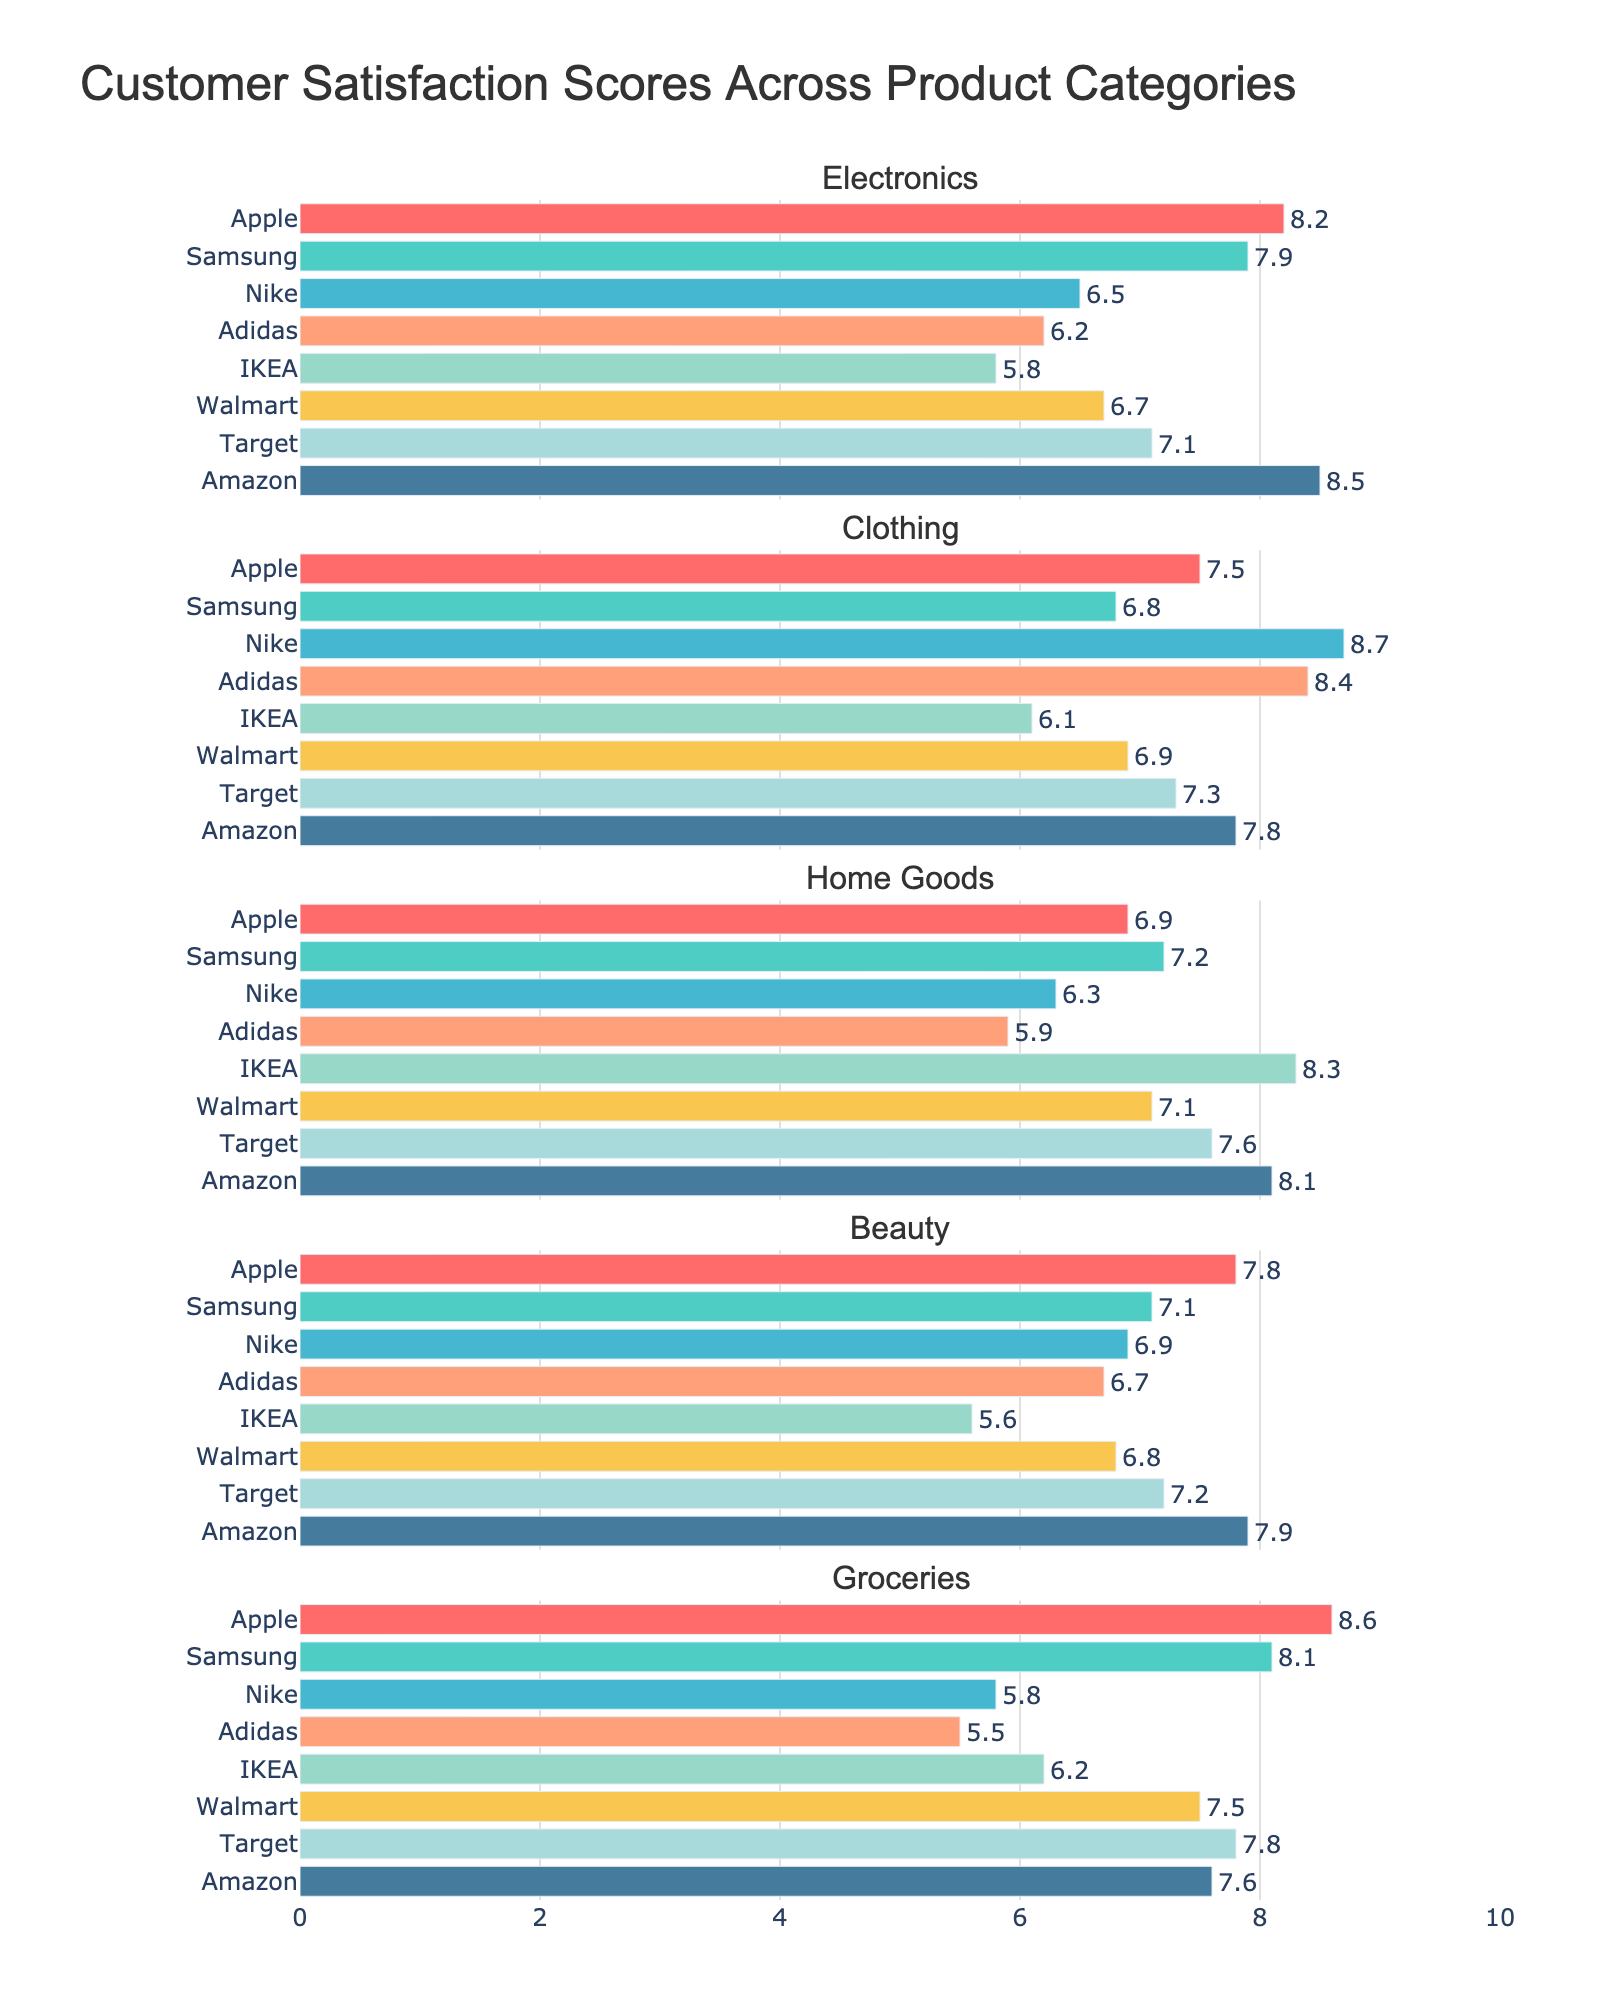What is the highest customer satisfaction score for Electronics? In the Electronics category subplot, identify the highest bar. The highest bar is for Amazon with a score of 8.5.
Answer: 8.5 Which brand has the lowest satisfaction score in the Beauty category? Look at the Beauty category subplot and identify the shortest bar. IKEA, with a score of 5.6, has the lowest satisfaction score.
Answer: IKEA What are the average satisfaction scores for Clothing and Home Goods categories? Calculate separately for each category by adding the scores and dividing by the number of brands. For Clothing: (7.5+6.8+8.7+8.4+6.1+6.9+7.3+7.8)/8 = 7.31; For Home Goods: (6.9+7.2+6.3+5.9+8.3+7.1+7.6+8.1)/8 = 7.05.
Answer: Clothing: 7.31, Home Goods: 7.05 Which two brands have the closest satisfaction scores in the Groceries category? Check the Groceries subplot and find the two bars with the closest heights. Apple (8.6) and Target (7.8) have the closest scores.
Answer: Apple and Target Is Apple’s satisfaction score in Groceries higher than in Beauty? Compare the height of Apple's bars in Groceries and Beauty subplots. Apple scores 8.6 in Groceries and 7.8 in Beauty.
Answer: Yes Which category does IKEA score highest in? Identify the subplot where IKEA’s bar is the tallest. IKEA scores highest in Home Goods with a score of 8.3.
Answer: Home Goods Which categories have higher satisfaction scores for Amazon compared to Samsung? Compare the bars for Amazon and Samsung across all subplots. Amazon scores higher in Electronics (Amazon: 8.5, Samsung: 7.9), Clothing (Amazon: 7.8, Samsung: 6.8), Home Goods (Amazon: 8.1, Samsung: 7.2), and Beauty (Amazon: 7.9, Samsung: 7.1).
Answer: Electronics, Clothing, Home Goods, Beauty How does Walmart's satisfaction score in Beauty compare to Target's satisfaction score in the same category? Observe the bars for Walmart and Target in the Beauty subplot. Walmart scores 6.8 and Target scores 7.2.
Answer: Target is higher What is the range of satisfaction scores for Nike across all categories? Identify the highest and lowest scores for Nike across all subplots. The highest is 8.7 in Clothing and the lowest is 5.8 in Groceries. The range is 8.7 - 5.8 = 2.9.
Answer: 2.9 In which categories does Apple have scores greater than 8? Check the subplots for Apple’s bars and identify those greater than 8. Apple scores above 8 in Electronics (8.2) and Groceries (8.6).
Answer: Electronics, Groceries 